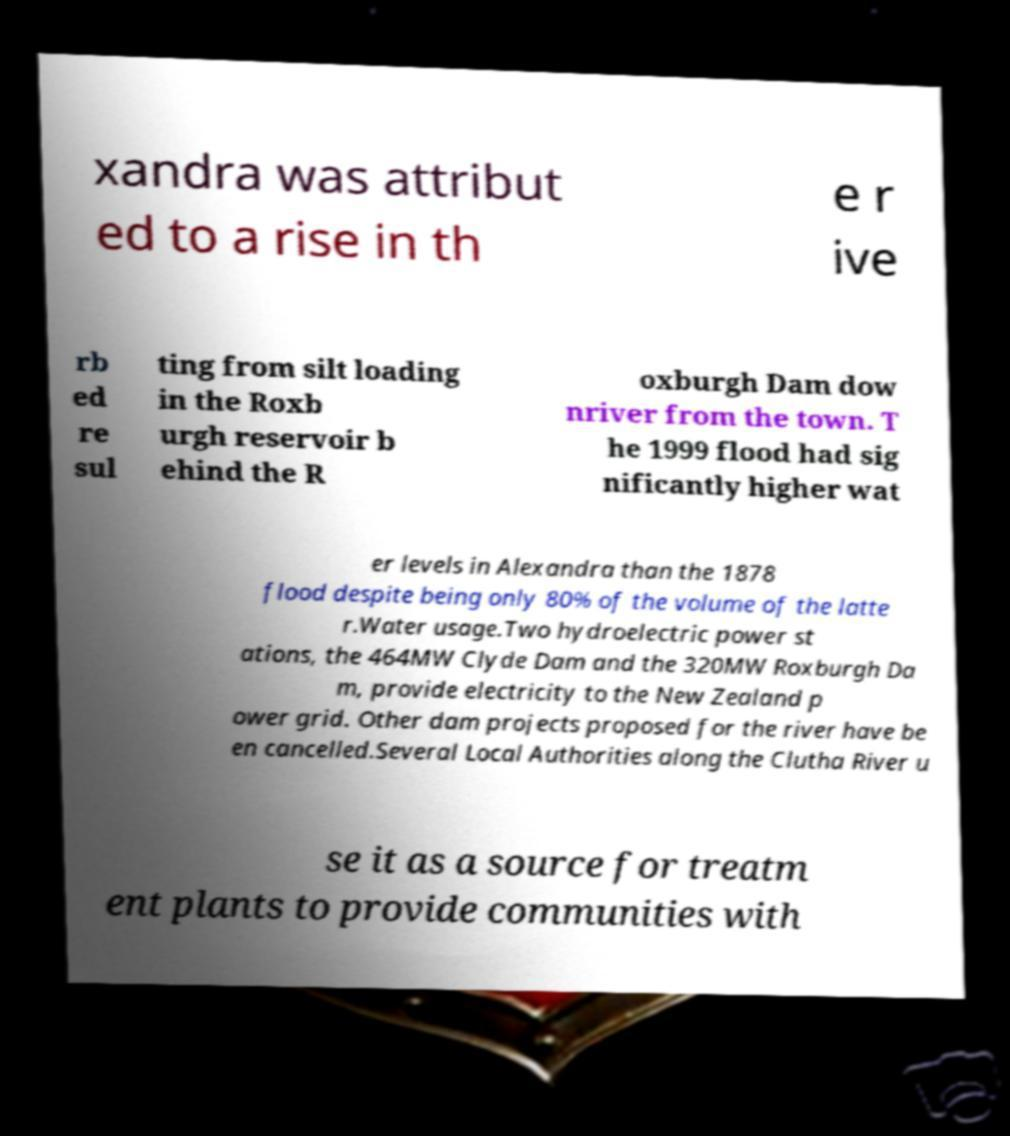Could you assist in decoding the text presented in this image and type it out clearly? xandra was attribut ed to a rise in th e r ive rb ed re sul ting from silt loading in the Roxb urgh reservoir b ehind the R oxburgh Dam dow nriver from the town. T he 1999 flood had sig nificantly higher wat er levels in Alexandra than the 1878 flood despite being only 80% of the volume of the latte r.Water usage.Two hydroelectric power st ations, the 464MW Clyde Dam and the 320MW Roxburgh Da m, provide electricity to the New Zealand p ower grid. Other dam projects proposed for the river have be en cancelled.Several Local Authorities along the Clutha River u se it as a source for treatm ent plants to provide communities with 